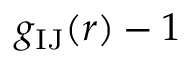<formula> <loc_0><loc_0><loc_500><loc_500>g _ { I J } ( r ) - 1</formula> 